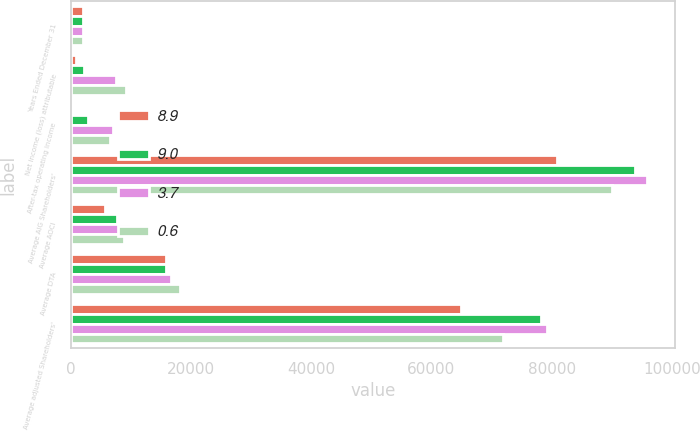Convert chart to OTSL. <chart><loc_0><loc_0><loc_500><loc_500><stacked_bar_chart><ecel><fcel>Years Ended December 31<fcel>Net income (loss) attributable<fcel>After-tax operating income<fcel>Average AIG Shareholders'<fcel>Average AOCI<fcel>Average DTA<fcel>Average adjusted Shareholders'<nl><fcel>8.9<fcel>2016<fcel>849<fcel>406<fcel>80895<fcel>5722<fcel>15905<fcel>64990<nl><fcel>9<fcel>2015<fcel>2196<fcel>2872<fcel>93960<fcel>7598<fcel>15803<fcel>78157<nl><fcel>3.7<fcel>2014<fcel>7529<fcel>6941<fcel>95808<fcel>9781<fcel>16611<fcel>79197<nl><fcel>0.6<fcel>2013<fcel>9085<fcel>6449<fcel>89985<fcel>8865<fcel>18150<fcel>71835<nl></chart> 